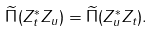Convert formula to latex. <formula><loc_0><loc_0><loc_500><loc_500>\widetilde { \Pi } ( Z _ { t } ^ { * } Z _ { u } ) = \widetilde { \Pi } ( Z _ { u } ^ { * } Z _ { t } ) .</formula> 